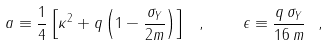<formula> <loc_0><loc_0><loc_500><loc_500>a \equiv \frac { 1 } { 4 } \left [ \kappa ^ { 2 } + q \left ( 1 - \frac { \sigma _ { Y } } { 2 m } \right ) \right ] \ , \quad \epsilon \equiv \frac { q \, \sigma _ { Y } } { 1 6 \, m } \ ,</formula> 